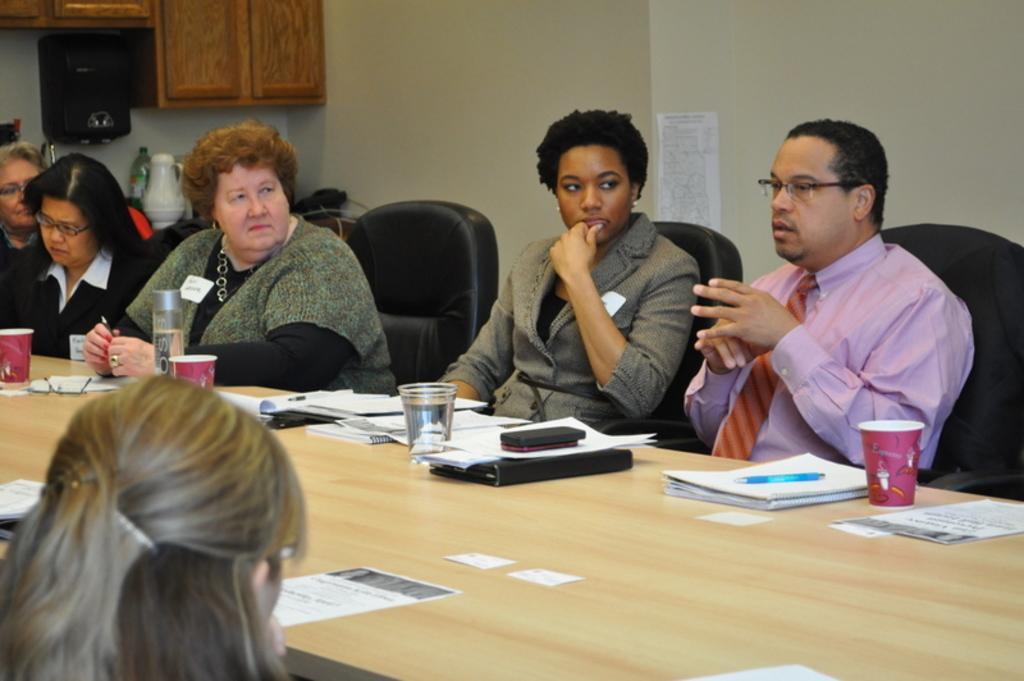How would you summarize this image in a sentence or two? Here I can see few people are sitting on the chairs around the table. The man who is sitting on the right side is speaking. The remaining people are looking at this man. On this table books, papers, classes, bottle, mobiles and some other objects are placed. In the background there is a wall on which a paper is attached. In the top left hand-corner there is a cupboard and also I can see a black color object which seems to be a speaker. At the back of these people there is a table on which few objects are placed. 